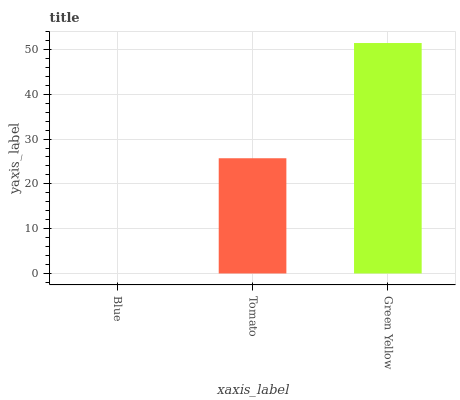Is Tomato the minimum?
Answer yes or no. No. Is Tomato the maximum?
Answer yes or no. No. Is Tomato greater than Blue?
Answer yes or no. Yes. Is Blue less than Tomato?
Answer yes or no. Yes. Is Blue greater than Tomato?
Answer yes or no. No. Is Tomato less than Blue?
Answer yes or no. No. Is Tomato the high median?
Answer yes or no. Yes. Is Tomato the low median?
Answer yes or no. Yes. Is Green Yellow the high median?
Answer yes or no. No. Is Green Yellow the low median?
Answer yes or no. No. 